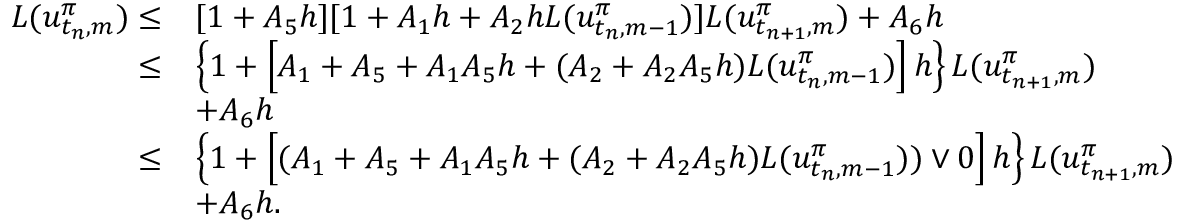Convert formula to latex. <formula><loc_0><loc_0><loc_500><loc_500>\begin{array} { r l } { L ( u _ { t _ { n } , m } ^ { \pi } ) \leq } & { [ 1 + A _ { 5 } h ] [ 1 + A _ { 1 } h + A _ { 2 } h L ( u _ { t _ { n } , m - 1 } ^ { \pi } ) ] L ( u _ { t _ { n + 1 } , m } ^ { \pi } ) + A _ { 6 } h } \\ { \leq } & { \left \{ 1 + \left [ A _ { 1 } + A _ { 5 } + A _ { 1 } A _ { 5 } h + ( A _ { 2 } + A _ { 2 } A _ { 5 } h ) L ( u _ { t _ { n } , m - 1 } ^ { \pi } ) \right ] h \right \} L ( u _ { t _ { n + 1 } , m } ^ { \pi } ) } \\ & { + A _ { 6 } h } \\ { \leq } & { \left \{ 1 + \left [ ( A _ { 1 } + A _ { 5 } + A _ { 1 } A _ { 5 } h + ( A _ { 2 } + A _ { 2 } A _ { 5 } h ) L ( u _ { t _ { n } , m - 1 } ^ { \pi } ) ) \vee 0 \right ] h \right \} L ( u _ { t _ { n + 1 } , m } ^ { \pi } ) } \\ & { + A _ { 6 } h . } \end{array}</formula> 